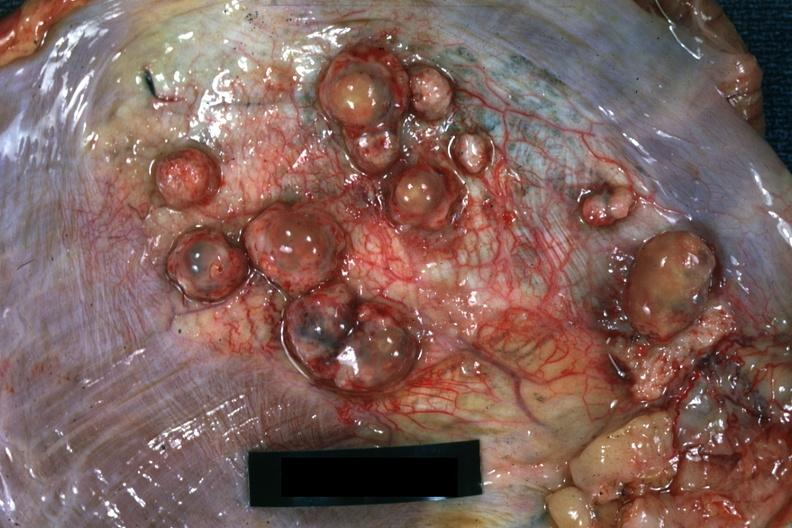what is present?
Answer the question using a single word or phrase. Soft tissue 